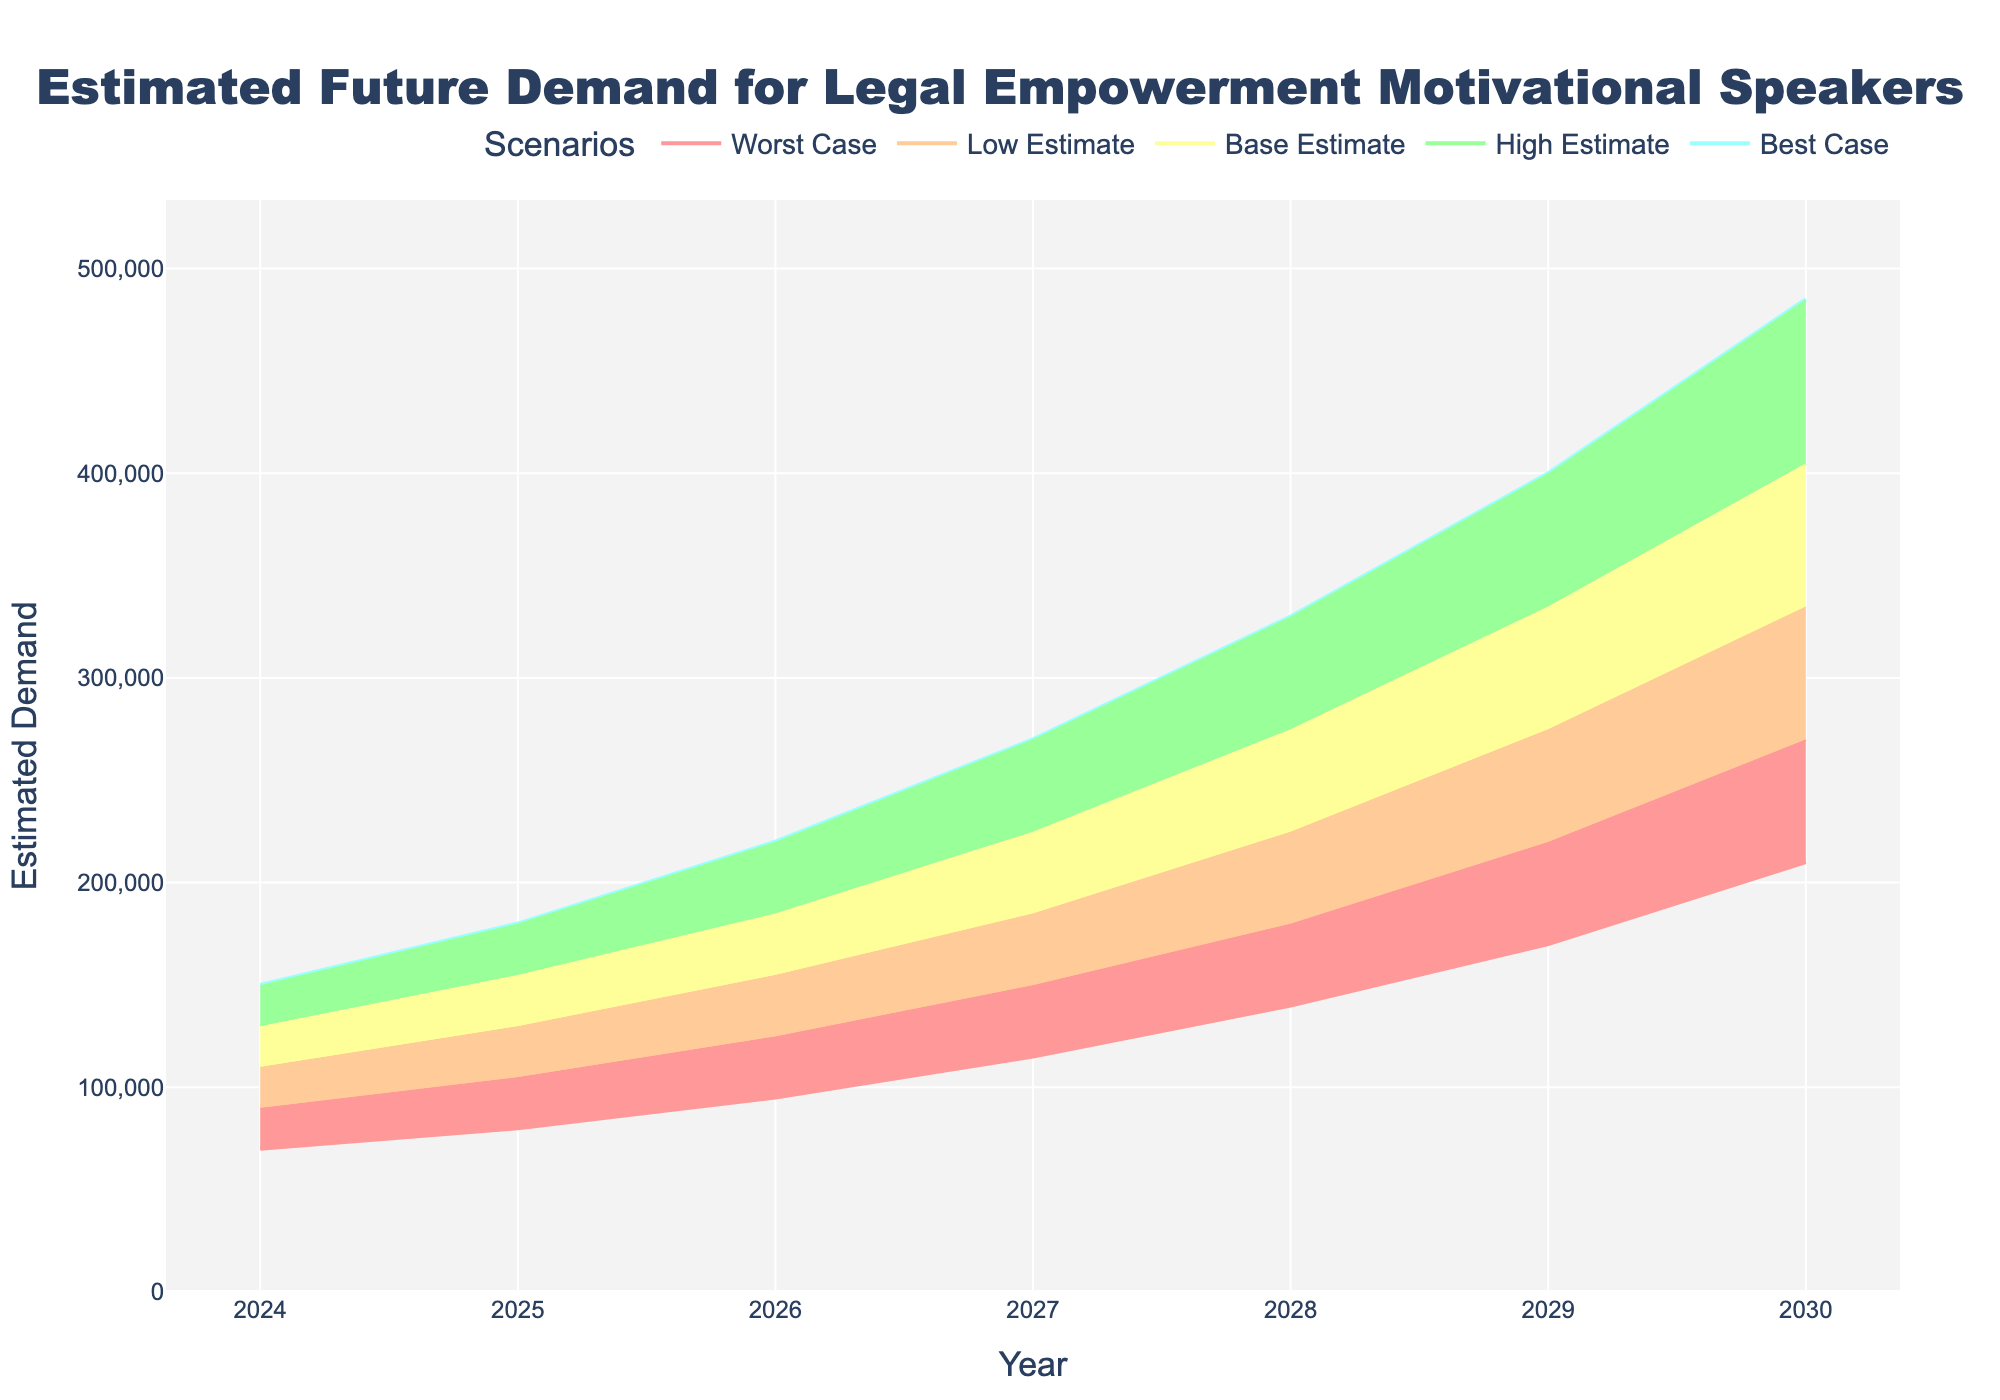What is the title of the figure? The title is displayed prominently at the top of the figure. It reads "Estimated Future Demand for Legal Empowerment Motivational Speakers".
Answer: Estimated Future Demand for Legal Empowerment Motivational Speakers What is the estimated demand in the Base Estimate scenario for the year 2026? The year 2026 on the x-axis corresponds to a demand of 155,000 in the Base Estimate scenario, as seen from the y-axis.
Answer: 155,000 Which year is projected to have the highest demand in the Best Case scenario? By following the Best Case line, the highest demand is for the year 2030, with a projected 485,000.
Answer: 2030 By how much does the High Estimate for 2025 exceed the Base Estimate for the same year? The High Estimate for 2025 is 155,000, and the Base Estimate for the same year is 130,000. The difference is calculated as 155,000 - 130,000 = 25,000.
Answer: 25,000 How do the Low Estimate and Worst Case scenarios compare for the year 2028? For the year 2028, the graph shows a Low Estimate of 180,000 and a Worst Case of 140,000. The Low Estimate is 40,000 higher than the Worst Case.
Answer: Low Estimate is 40,000 higher What is the average Base Estimate demand over the years 2024 to 2027? The Base Estimate demands for the years 2024 to 2027 are 110,000, 130,000, 155,000, and 185,000 respectively. The average is calculated by summing these values and dividing by the number of years: (110,000 + 130,000 + 155,000 + 185,000) / 4 = 145,000.
Answer: 145,000 What is the range of demand in the year 2029 from Worst Case to Best Case scenarios? In 2029, the Worst Case scenario shows 170,000 and the Best Case scenario shows 400,000. The range is 400,000 - 170,000 = 230,000.
Answer: 230,000 By what percentage is the 2030 Best Case higher than the 2024 Best Case? The Best Case for 2030 is 485,000, and for 2024 it is 150,000. The percentage increase is calculated by ((485,000 - 150,000) / 150,000) * 100 = 223%.
Answer: 223% What trend do you observe in the demand estimates over the years? All demand estimates (Best Case, High Estimate, Base Estimate, Low Estimate, Worst Case) show an increasing trend from 2024 to 2030, indicating growth in estimated demand over time.
Answer: Increasing trend Which scenario shows the smallest growth from 2024 to 2030? Comparing the growth for each scenario, the Worst Case starts from 70,000 in 2024 and reaches 210,000 in 2030, a growth of 210,000 - 70,000 = 140,000. This is the smallest growth compared to other scenarios.
Answer: Worst Case scenario 